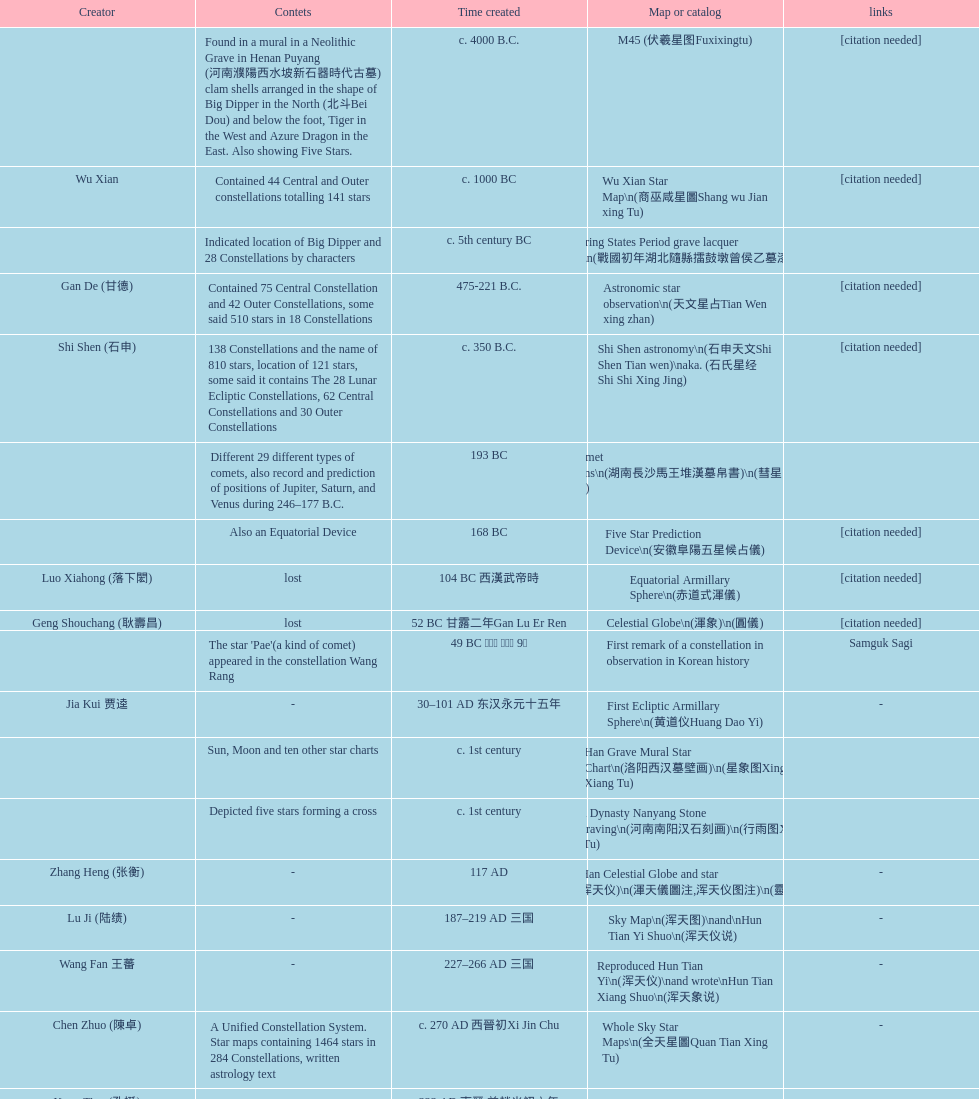Which astronomical map was made earlier, celestial globe or the han burial site star chart? Celestial Globe. 